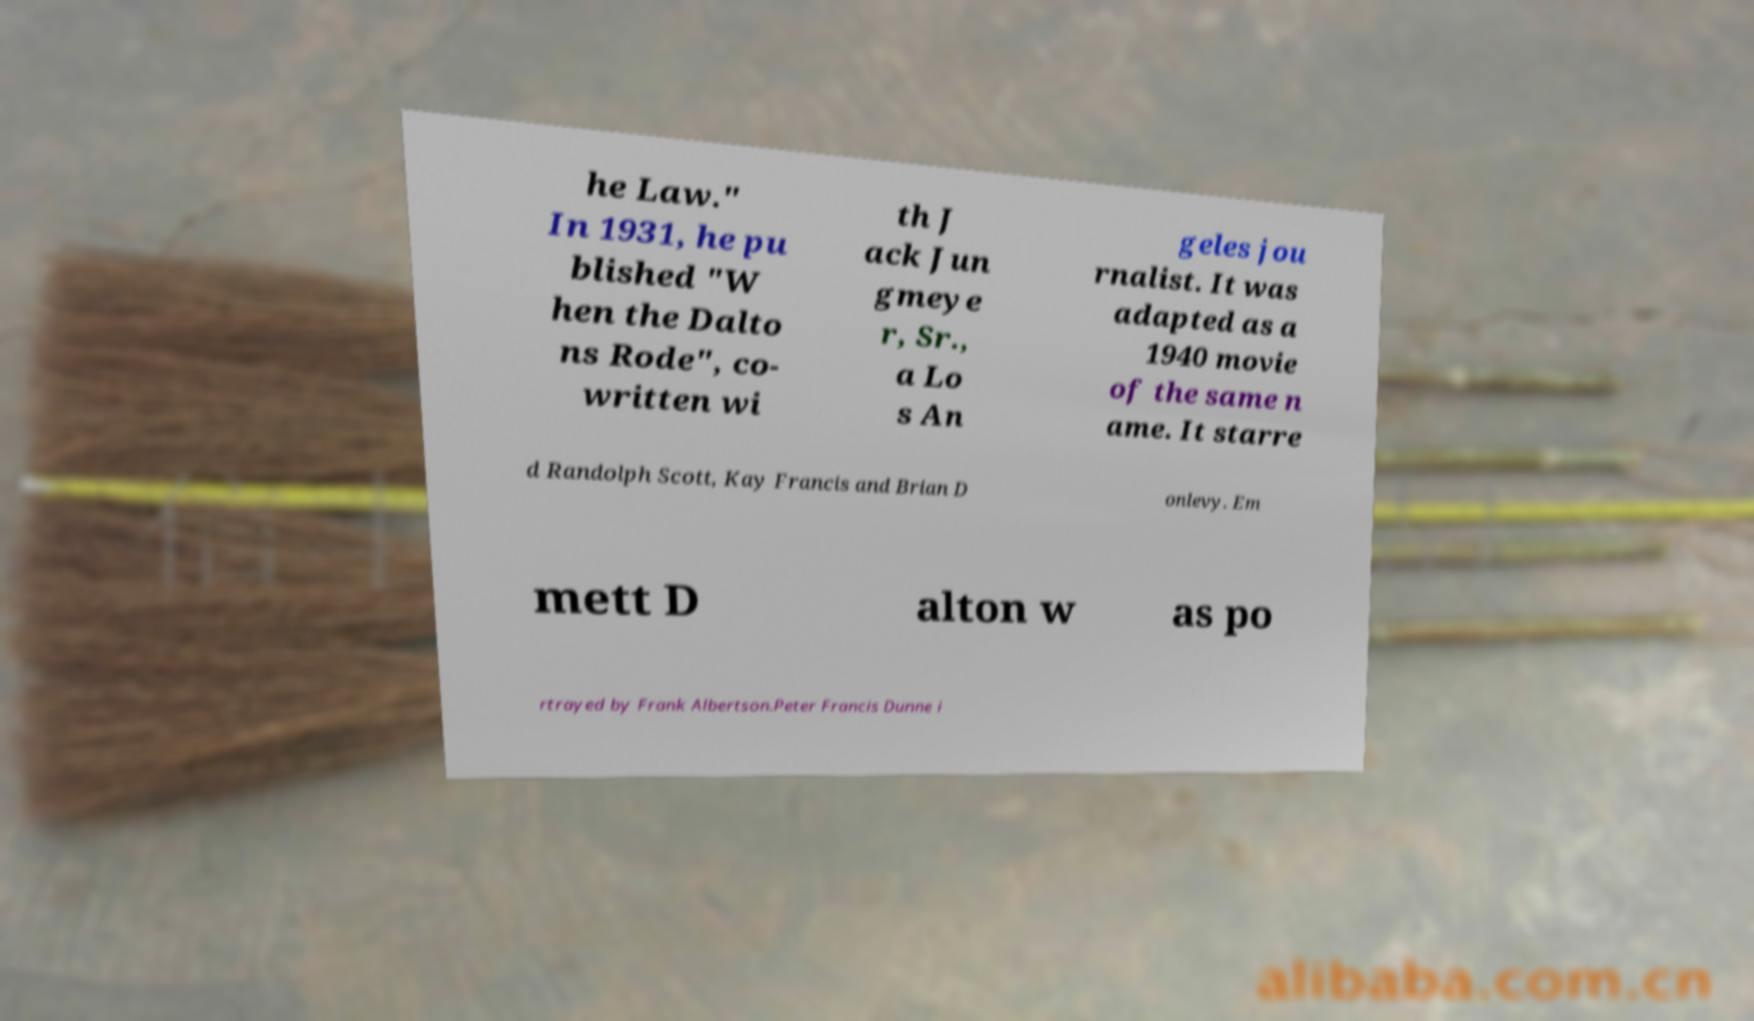I need the written content from this picture converted into text. Can you do that? he Law." In 1931, he pu blished "W hen the Dalto ns Rode", co- written wi th J ack Jun gmeye r, Sr., a Lo s An geles jou rnalist. It was adapted as a 1940 movie of the same n ame. It starre d Randolph Scott, Kay Francis and Brian D onlevy. Em mett D alton w as po rtrayed by Frank Albertson.Peter Francis Dunne i 